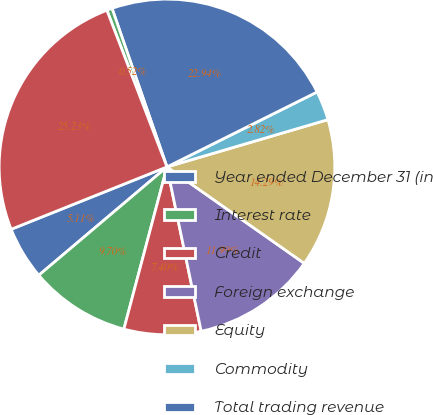<chart> <loc_0><loc_0><loc_500><loc_500><pie_chart><fcel>Year ended December 31 (in<fcel>Interest rate<fcel>Credit<fcel>Foreign exchange<fcel>Equity<fcel>Commodity<fcel>Total trading revenue<fcel>Private equity gains (a)<fcel>Principal transactions<nl><fcel>5.11%<fcel>9.7%<fcel>7.4%<fcel>11.99%<fcel>14.29%<fcel>2.82%<fcel>22.94%<fcel>0.52%<fcel>25.23%<nl></chart> 